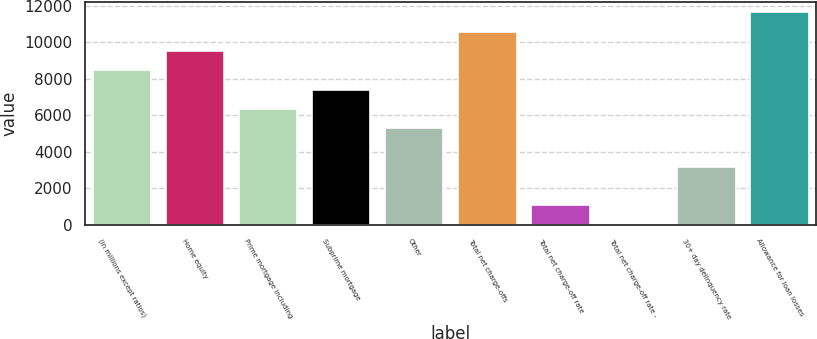<chart> <loc_0><loc_0><loc_500><loc_500><bar_chart><fcel>(in millions except ratios)<fcel>Home equity<fcel>Prime mortgage including<fcel>Subprime mortgage<fcel>Other<fcel>Total net charge-offs<fcel>Total net charge-off rate<fcel>Total net charge-off rate -<fcel>30+ day delinquency rate<fcel>Allowance for loan losses<nl><fcel>8463.55<fcel>9521.27<fcel>6348.11<fcel>7405.83<fcel>5290.39<fcel>10579<fcel>1059.51<fcel>1.79<fcel>3174.95<fcel>11636.7<nl></chart> 